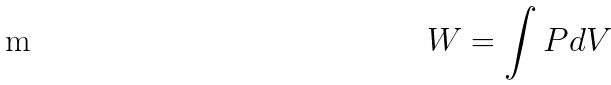Convert formula to latex. <formula><loc_0><loc_0><loc_500><loc_500>W = \int P d V</formula> 